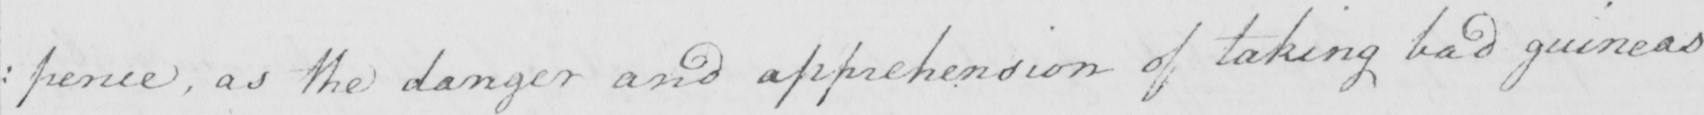Transcribe the text shown in this historical manuscript line. : pence , as the danger and apprehension of taking bad guineas 